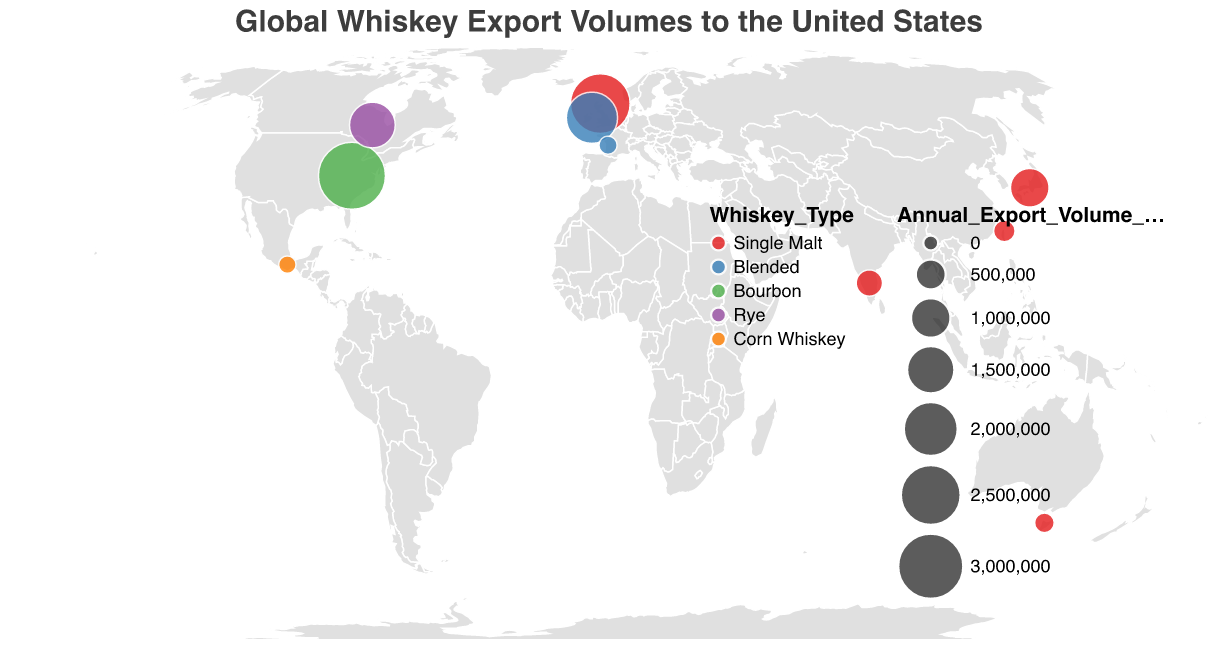What's the title of the figure? The title of the figure is displayed at the top and is visually larger than the other text elements in the plot.
Answer: Global Whiskey Export Volumes to the United States Which country exports the most whiskey to the United States? By examining the sizes of the circles, the largest circle indicates the country with the highest export volume. The largest circle is located in the USA for Kentucky Bourbon.
Answer: USA Which whiskey type has the smallest export volume to the United States, and from which country? The smallest circle indicates the lowest export volume. By identifying the smallest circle and referring to its tooltip, we find that Corn Whiskey from Mexico has the smallest export volume.
Answer: Corn Whiskey from Mexico How many countries are represented in the figure? Count the total number of circles on the geographic plot. Each circle represents a different country.
Answer: 10 Which whiskey type is represented by the most exporting countries? Count the number of occurrences of each whiskey type by examining the color of the circles. The whiskey type with the most circles represents the most exporting countries.
Answer: Single Malt What is the combined export volume of whiskey from Ireland and Japan to the United States? Sum the export volumes from Ireland (1,800,000 liters) and Japan (950,000 liters).
Answer: 2,750,000 liters Compare the export volumes of Single Malt whiskey from Scotland and Ireland. Which one is higher, and by how much? Identify the export volumes of Single Malt whiskey from Scotland (2,500,000 liters) and Blended whiskey from Ireland (1,800,000 liters). Subtract the smaller volume from the larger volume to find the difference.
Answer: Scotland by 700,000 liters Which regions are exporting Single Malt whiskey to the United States? Identify the locations of circles with the color corresponding to Single Malt whiskey, then read the region names from the tooltips.
Answer: Speyside, Yamazaki, Bangalore, Yilan, Tasmania What is the average export volume of the different whiskey types to the United States? Add up all export volumes, then divide by the number of whiskey types (5). Sum: 2,500,000 + 1,800,000 + 3,200,000 + 950,000 + 1,400,000 + 350,000 + 180,000 + 120,000 + 80,000 + 60,000 = 10,640,000 liters. Divide by 5.
Answer: 2,128,000 liters Among the Single Malt exporting countries, which one has the lowest export volume? Identify the circles for Single Malt whiskey and compare export volumes to find the smallest.
Answer: Australia 